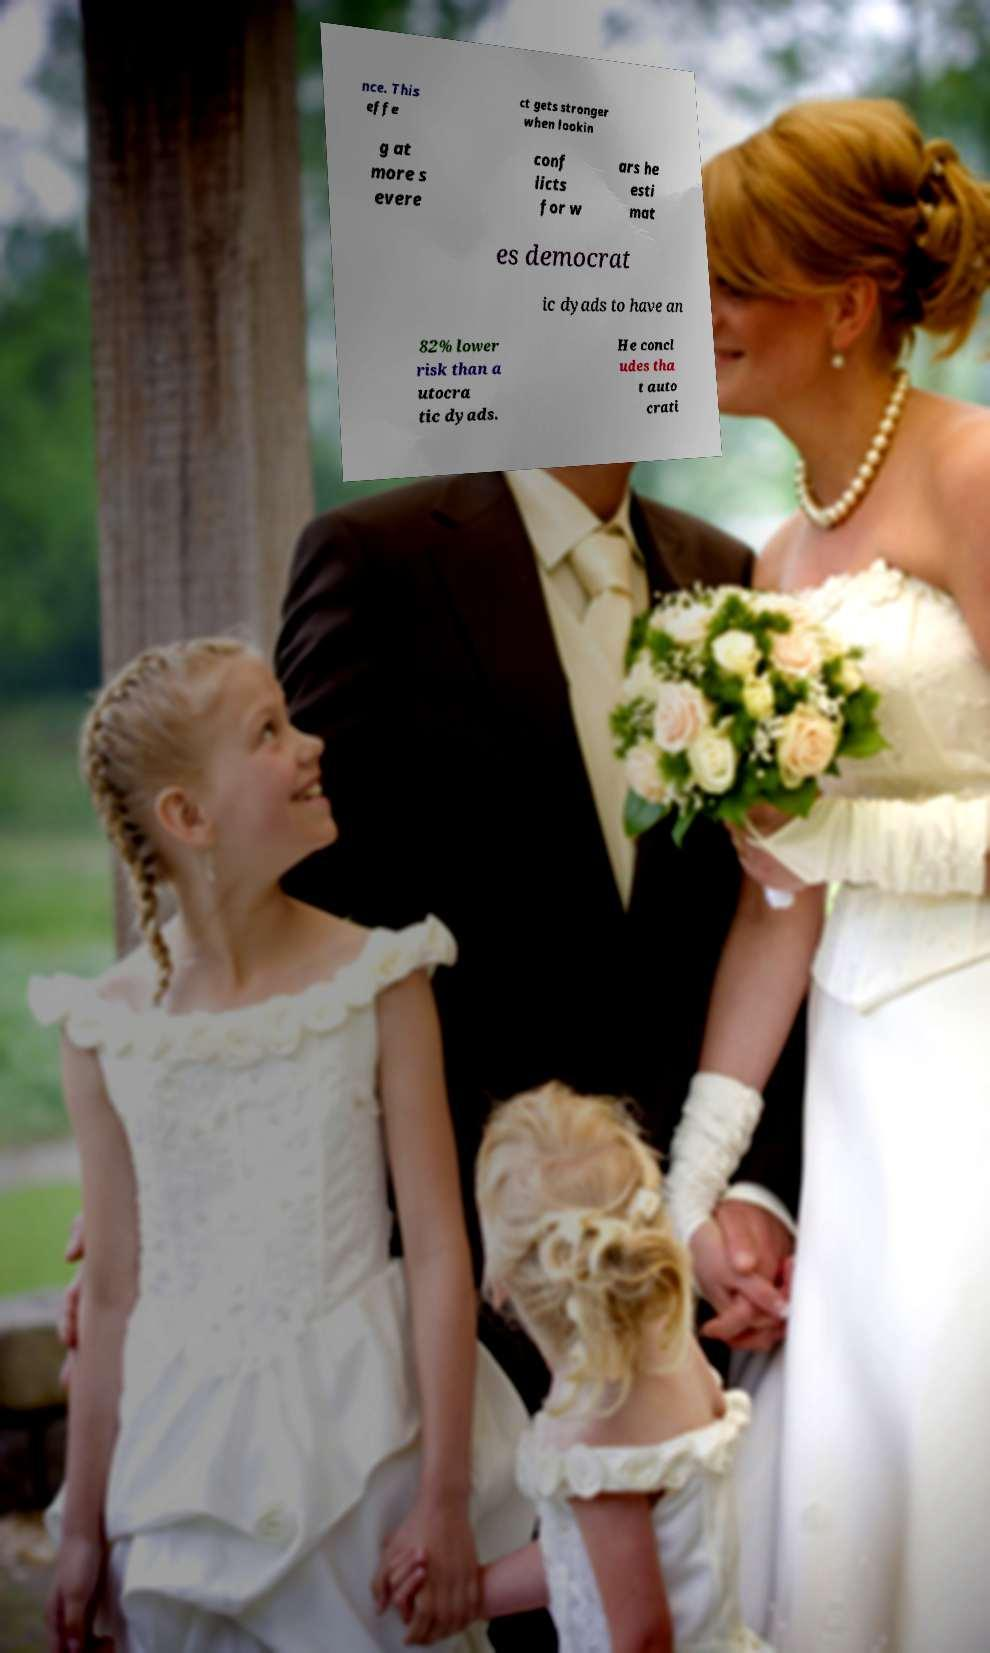Please identify and transcribe the text found in this image. nce. This effe ct gets stronger when lookin g at more s evere conf licts for w ars he esti mat es democrat ic dyads to have an 82% lower risk than a utocra tic dyads. He concl udes tha t auto crati 